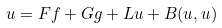Convert formula to latex. <formula><loc_0><loc_0><loc_500><loc_500>u = F f + G g + L u + B ( u , u )</formula> 